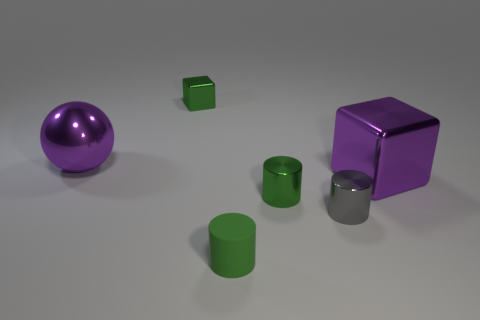Add 3 big cyan shiny cylinders. How many objects exist? 9 Subtract all blocks. How many objects are left? 4 Subtract all big purple metallic balls. Subtract all green metallic cylinders. How many objects are left? 4 Add 1 tiny blocks. How many tiny blocks are left? 2 Add 3 tiny red rubber cylinders. How many tiny red rubber cylinders exist? 3 Subtract 1 purple spheres. How many objects are left? 5 